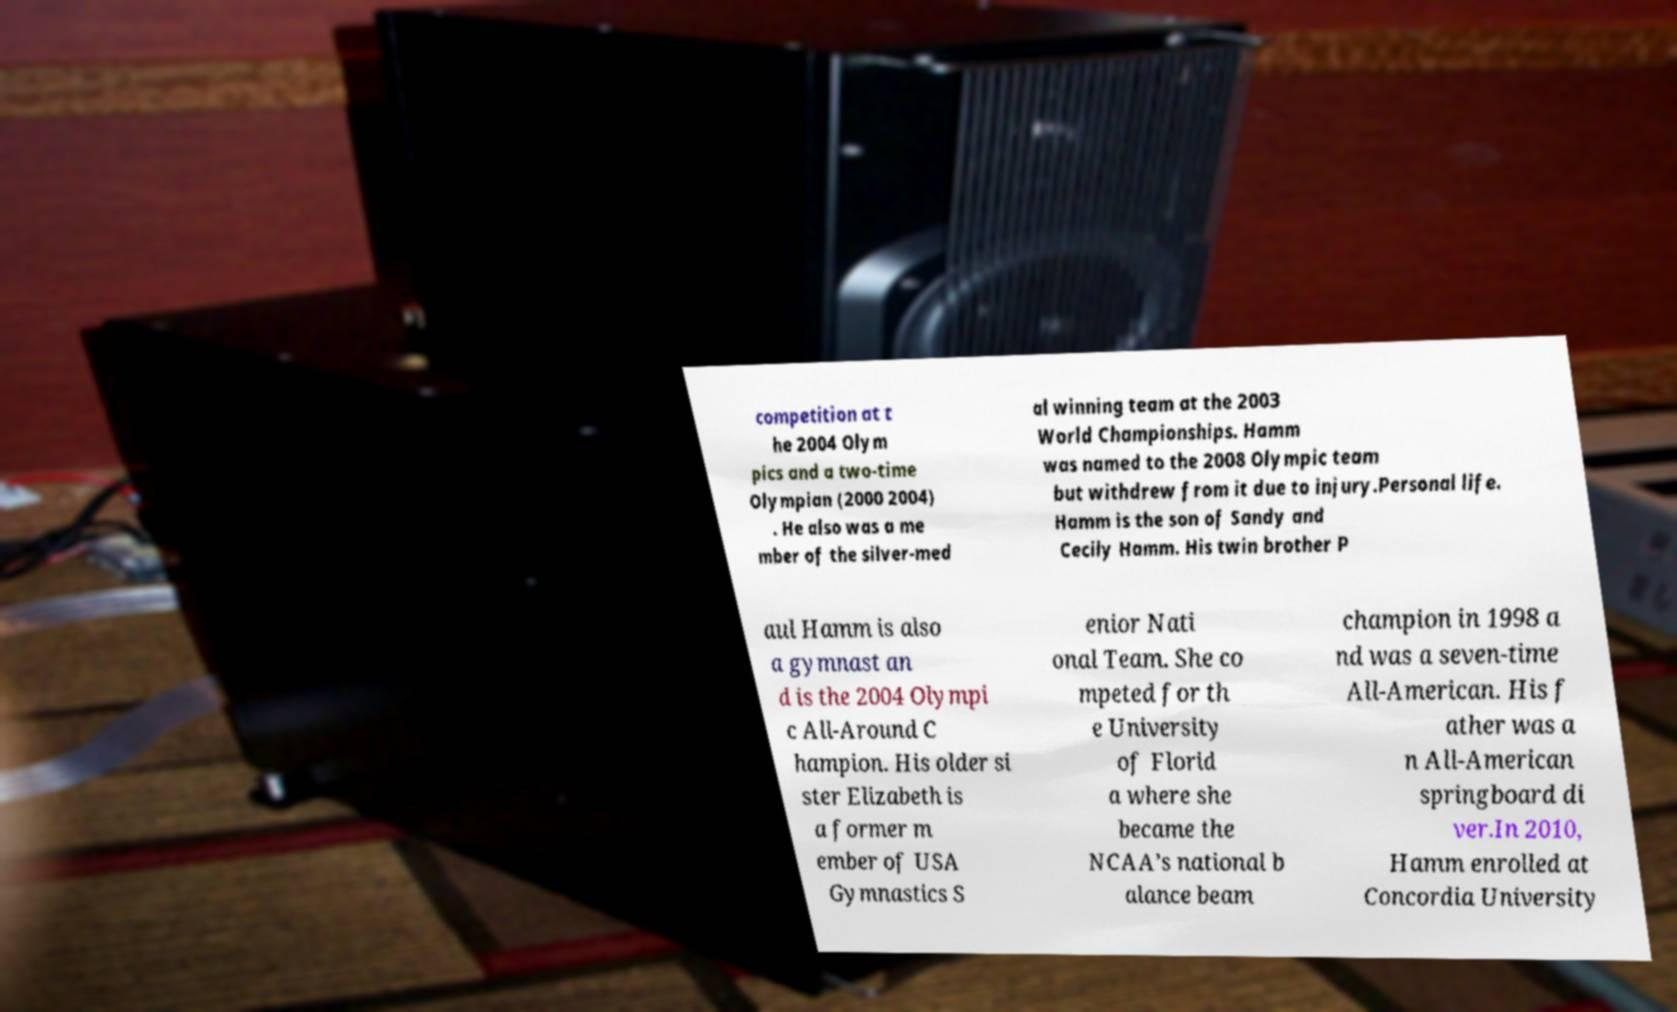Please identify and transcribe the text found in this image. competition at t he 2004 Olym pics and a two-time Olympian (2000 2004) . He also was a me mber of the silver-med al winning team at the 2003 World Championships. Hamm was named to the 2008 Olympic team but withdrew from it due to injury.Personal life. Hamm is the son of Sandy and Cecily Hamm. His twin brother P aul Hamm is also a gymnast an d is the 2004 Olympi c All-Around C hampion. His older si ster Elizabeth is a former m ember of USA Gymnastics S enior Nati onal Team. She co mpeted for th e University of Florid a where she became the NCAA’s national b alance beam champion in 1998 a nd was a seven-time All-American. His f ather was a n All-American springboard di ver.In 2010, Hamm enrolled at Concordia University 